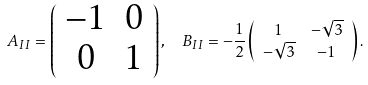<formula> <loc_0><loc_0><loc_500><loc_500>A _ { I I } = \left ( \begin{array} { c c } - 1 & 0 \\ 0 & 1 \end{array} \right ) , & \quad B _ { I I } = - \frac { 1 } { 2 } \left ( \begin{array} { c c } 1 & - \sqrt { 3 } \\ - \sqrt { 3 } & - 1 \end{array} \right ) .</formula> 